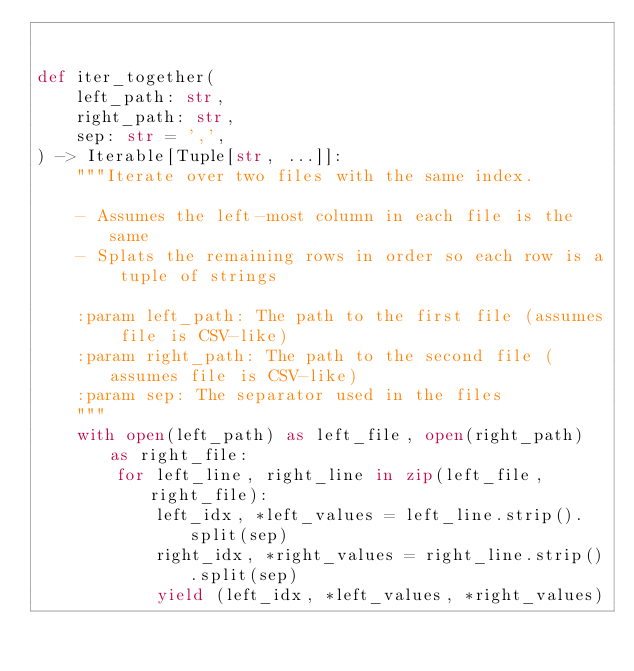<code> <loc_0><loc_0><loc_500><loc_500><_Python_>

def iter_together(
    left_path: str,
    right_path: str,
    sep: str = ',',
) -> Iterable[Tuple[str, ...]]:
    """Iterate over two files with the same index.

    - Assumes the left-most column in each file is the same
    - Splats the remaining rows in order so each row is a tuple of strings

    :param left_path: The path to the first file (assumes file is CSV-like)
    :param right_path: The path to the second file (assumes file is CSV-like)
    :param sep: The separator used in the files
    """
    with open(left_path) as left_file, open(right_path) as right_file:
        for left_line, right_line in zip(left_file, right_file):
            left_idx, *left_values = left_line.strip().split(sep)
            right_idx, *right_values = right_line.strip().split(sep)
            yield (left_idx, *left_values, *right_values)
</code> 